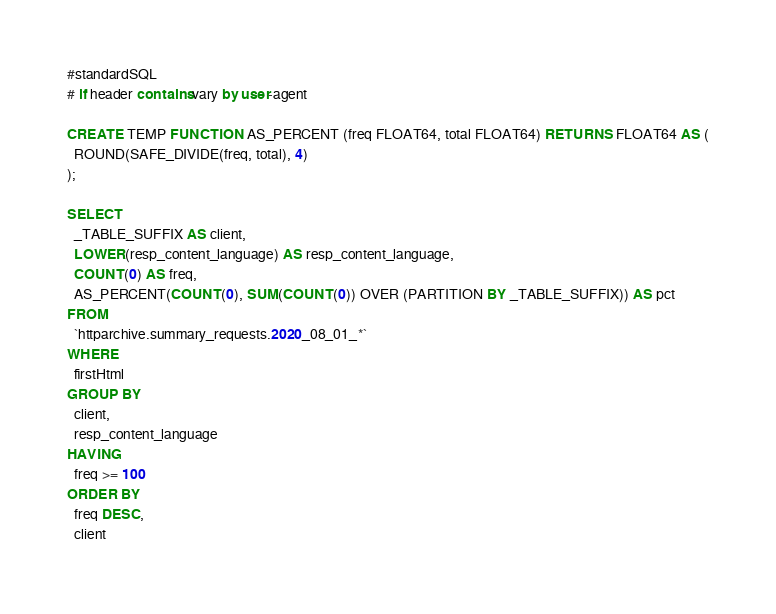Convert code to text. <code><loc_0><loc_0><loc_500><loc_500><_SQL_>#standardSQL
# if header contains vary by user-agent

CREATE TEMP FUNCTION AS_PERCENT (freq FLOAT64, total FLOAT64) RETURNS FLOAT64 AS (
  ROUND(SAFE_DIVIDE(freq, total), 4)
);

SELECT
  _TABLE_SUFFIX AS client,
  LOWER(resp_content_language) AS resp_content_language,
  COUNT(0) AS freq,
  AS_PERCENT(COUNT(0), SUM(COUNT(0)) OVER (PARTITION BY _TABLE_SUFFIX)) AS pct
FROM
  `httparchive.summary_requests.2020_08_01_*`
WHERE
  firstHtml
GROUP BY
  client,
  resp_content_language
HAVING
  freq >= 100
ORDER BY
  freq DESC,
  client
</code> 